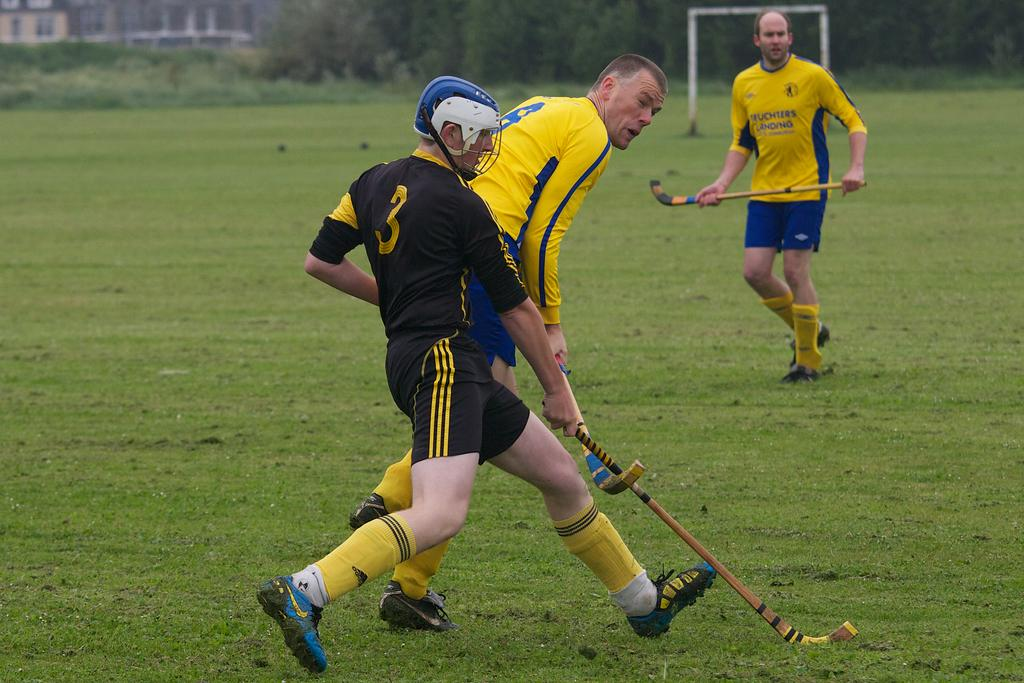How many people are in the image? There are three people in the image. What are the people wearing? The people are wearing sports dress. What objects are the people holding? The people are holding hockey sticks. What can be seen in the background of the image? There are trees, a net, and a building in the background of the image. Is there a bridge visible in the image? No, there is no bridge present in the image. What type of recess activity are the people participating in the image? The image does not depict a recess activity; the people are holding hockey sticks, which suggests they might be playing hockey. 